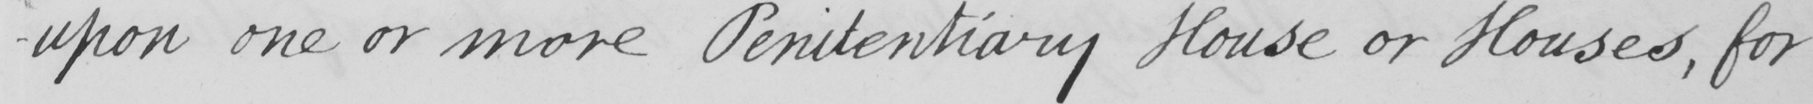Can you read and transcribe this handwriting? -upon one or more Penitentiary House or Houses , for 